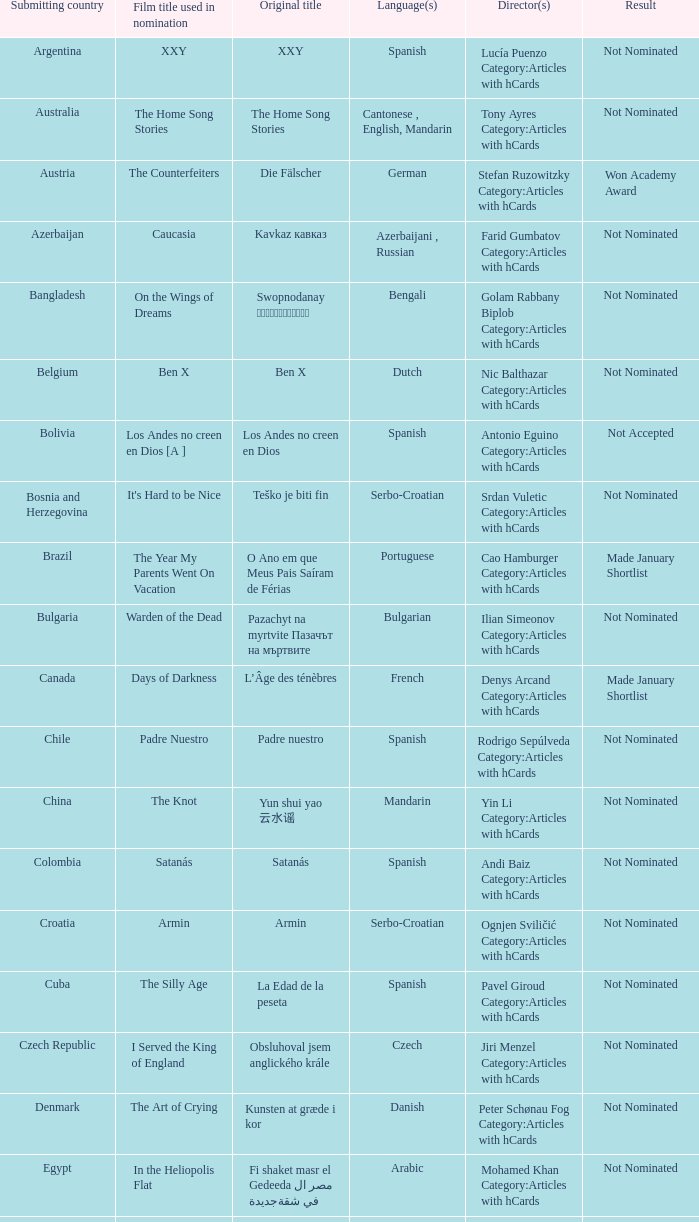What country submitted the movie the orphanage? Spain. 